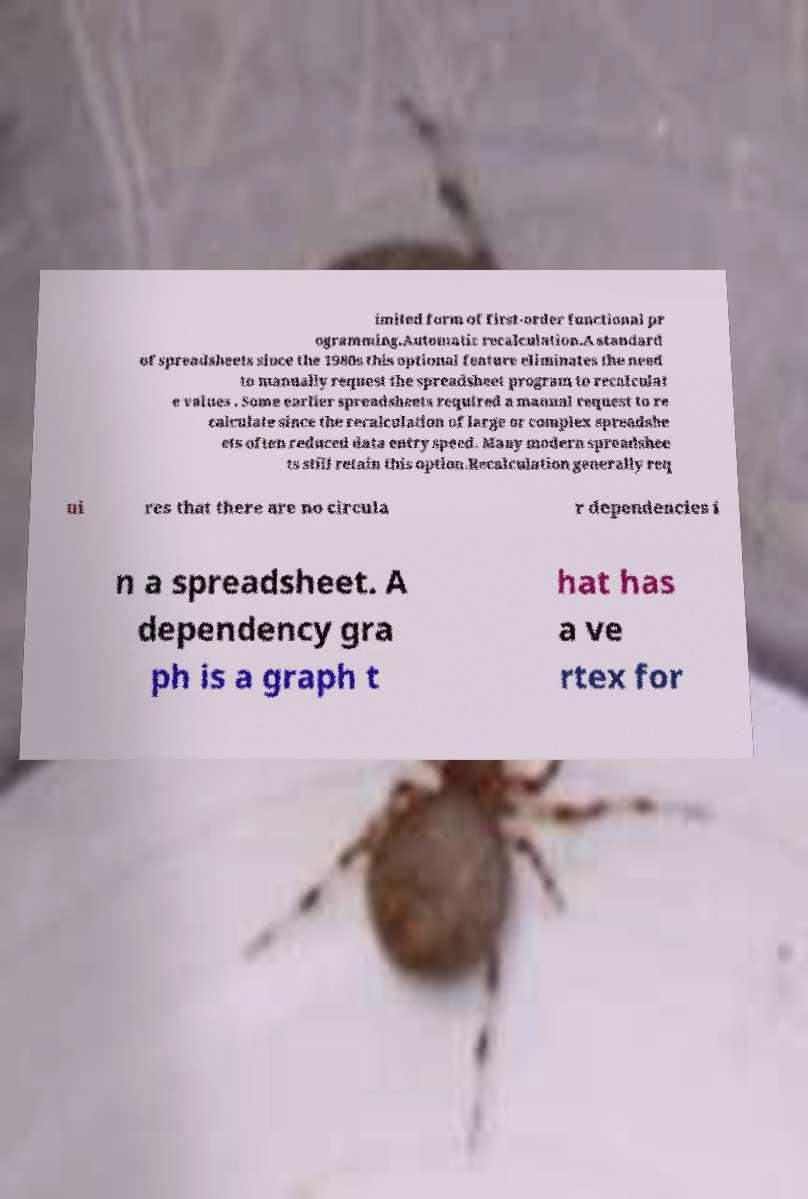Please identify and transcribe the text found in this image. imited form of first-order functional pr ogramming.Automatic recalculation.A standard of spreadsheets since the 1980s this optional feature eliminates the need to manually request the spreadsheet program to recalculat e values . Some earlier spreadsheets required a manual request to re calculate since the recalculation of large or complex spreadshe ets often reduced data entry speed. Many modern spreadshee ts still retain this option.Recalculation generally req ui res that there are no circula r dependencies i n a spreadsheet. A dependency gra ph is a graph t hat has a ve rtex for 